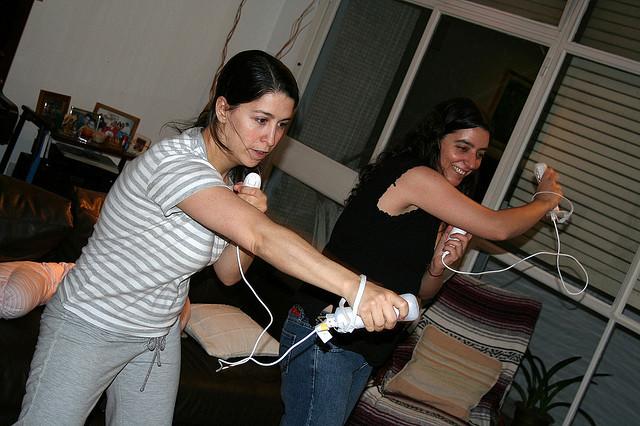What color are the people's shirts?
Answer briefly. Gray and black. What are the girls holding?
Be succinct. Wii remotes. What object are these girls looking at?
Keep it brief. Tv. Are they laughing?
Keep it brief. No. Are they having a family concert?
Keep it brief. No. 